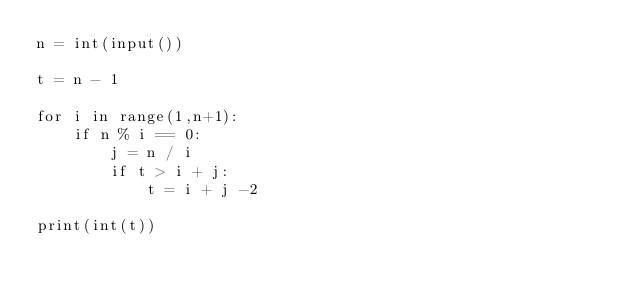Convert code to text. <code><loc_0><loc_0><loc_500><loc_500><_Python_>n = int(input())

t = n - 1

for i in range(1,n+1):
    if n % i == 0:
        j = n / i
        if t > i + j:
            t = i + j -2

print(int(t))
</code> 